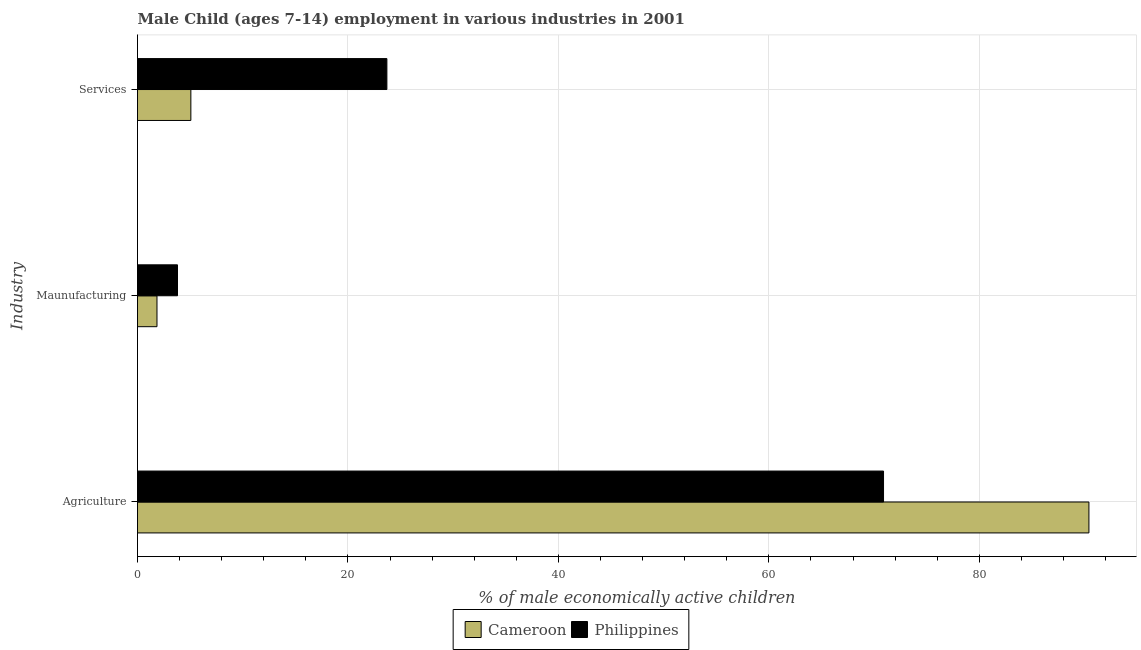How many different coloured bars are there?
Offer a very short reply. 2. How many groups of bars are there?
Offer a very short reply. 3. Are the number of bars per tick equal to the number of legend labels?
Your response must be concise. Yes. How many bars are there on the 2nd tick from the bottom?
Keep it short and to the point. 2. What is the label of the 3rd group of bars from the top?
Ensure brevity in your answer.  Agriculture. What is the percentage of economically active children in manufacturing in Cameroon?
Your response must be concise. 1.85. Across all countries, what is the maximum percentage of economically active children in services?
Provide a short and direct response. 23.7. Across all countries, what is the minimum percentage of economically active children in agriculture?
Provide a short and direct response. 70.9. In which country was the percentage of economically active children in agriculture maximum?
Provide a succinct answer. Cameroon. In which country was the percentage of economically active children in services minimum?
Your response must be concise. Cameroon. What is the total percentage of economically active children in agriculture in the graph?
Provide a short and direct response. 161.32. What is the difference between the percentage of economically active children in manufacturing in Cameroon and that in Philippines?
Provide a succinct answer. -1.95. What is the difference between the percentage of economically active children in agriculture in Cameroon and the percentage of economically active children in services in Philippines?
Your response must be concise. 66.72. What is the average percentage of economically active children in manufacturing per country?
Your response must be concise. 2.83. What is the difference between the percentage of economically active children in services and percentage of economically active children in agriculture in Cameroon?
Your response must be concise. -85.35. In how many countries, is the percentage of economically active children in manufacturing greater than 12 %?
Your response must be concise. 0. What is the ratio of the percentage of economically active children in services in Cameroon to that in Philippines?
Your response must be concise. 0.21. Is the percentage of economically active children in agriculture in Cameroon less than that in Philippines?
Your answer should be compact. No. What is the difference between the highest and the second highest percentage of economically active children in agriculture?
Make the answer very short. 19.52. What is the difference between the highest and the lowest percentage of economically active children in agriculture?
Give a very brief answer. 19.52. In how many countries, is the percentage of economically active children in services greater than the average percentage of economically active children in services taken over all countries?
Your answer should be compact. 1. Is the sum of the percentage of economically active children in agriculture in Cameroon and Philippines greater than the maximum percentage of economically active children in services across all countries?
Ensure brevity in your answer.  Yes. What does the 2nd bar from the top in Agriculture represents?
Provide a succinct answer. Cameroon. What does the 2nd bar from the bottom in Services represents?
Your answer should be compact. Philippines. Is it the case that in every country, the sum of the percentage of economically active children in agriculture and percentage of economically active children in manufacturing is greater than the percentage of economically active children in services?
Your answer should be very brief. Yes. What is the difference between two consecutive major ticks on the X-axis?
Provide a short and direct response. 20. Does the graph contain grids?
Give a very brief answer. Yes. How many legend labels are there?
Ensure brevity in your answer.  2. What is the title of the graph?
Make the answer very short. Male Child (ages 7-14) employment in various industries in 2001. What is the label or title of the X-axis?
Ensure brevity in your answer.  % of male economically active children. What is the label or title of the Y-axis?
Your response must be concise. Industry. What is the % of male economically active children in Cameroon in Agriculture?
Make the answer very short. 90.42. What is the % of male economically active children of Philippines in Agriculture?
Your answer should be very brief. 70.9. What is the % of male economically active children of Cameroon in Maunufacturing?
Offer a very short reply. 1.85. What is the % of male economically active children of Philippines in Maunufacturing?
Provide a succinct answer. 3.8. What is the % of male economically active children of Cameroon in Services?
Your response must be concise. 5.07. What is the % of male economically active children in Philippines in Services?
Provide a short and direct response. 23.7. Across all Industry, what is the maximum % of male economically active children in Cameroon?
Provide a short and direct response. 90.42. Across all Industry, what is the maximum % of male economically active children in Philippines?
Provide a short and direct response. 70.9. Across all Industry, what is the minimum % of male economically active children in Cameroon?
Offer a terse response. 1.85. What is the total % of male economically active children in Cameroon in the graph?
Your response must be concise. 97.34. What is the total % of male economically active children of Philippines in the graph?
Give a very brief answer. 98.4. What is the difference between the % of male economically active children in Cameroon in Agriculture and that in Maunufacturing?
Provide a short and direct response. 88.57. What is the difference between the % of male economically active children of Philippines in Agriculture and that in Maunufacturing?
Your answer should be compact. 67.1. What is the difference between the % of male economically active children of Cameroon in Agriculture and that in Services?
Ensure brevity in your answer.  85.35. What is the difference between the % of male economically active children in Philippines in Agriculture and that in Services?
Ensure brevity in your answer.  47.2. What is the difference between the % of male economically active children in Cameroon in Maunufacturing and that in Services?
Make the answer very short. -3.22. What is the difference between the % of male economically active children in Philippines in Maunufacturing and that in Services?
Offer a terse response. -19.9. What is the difference between the % of male economically active children of Cameroon in Agriculture and the % of male economically active children of Philippines in Maunufacturing?
Your response must be concise. 86.62. What is the difference between the % of male economically active children in Cameroon in Agriculture and the % of male economically active children in Philippines in Services?
Your answer should be very brief. 66.72. What is the difference between the % of male economically active children of Cameroon in Maunufacturing and the % of male economically active children of Philippines in Services?
Make the answer very short. -21.85. What is the average % of male economically active children of Cameroon per Industry?
Give a very brief answer. 32.45. What is the average % of male economically active children of Philippines per Industry?
Offer a very short reply. 32.8. What is the difference between the % of male economically active children in Cameroon and % of male economically active children in Philippines in Agriculture?
Your answer should be very brief. 19.52. What is the difference between the % of male economically active children of Cameroon and % of male economically active children of Philippines in Maunufacturing?
Ensure brevity in your answer.  -1.95. What is the difference between the % of male economically active children in Cameroon and % of male economically active children in Philippines in Services?
Ensure brevity in your answer.  -18.63. What is the ratio of the % of male economically active children of Cameroon in Agriculture to that in Maunufacturing?
Your answer should be very brief. 48.88. What is the ratio of the % of male economically active children of Philippines in Agriculture to that in Maunufacturing?
Keep it short and to the point. 18.66. What is the ratio of the % of male economically active children in Cameroon in Agriculture to that in Services?
Give a very brief answer. 17.83. What is the ratio of the % of male economically active children in Philippines in Agriculture to that in Services?
Offer a very short reply. 2.99. What is the ratio of the % of male economically active children of Cameroon in Maunufacturing to that in Services?
Your answer should be very brief. 0.36. What is the ratio of the % of male economically active children of Philippines in Maunufacturing to that in Services?
Offer a very short reply. 0.16. What is the difference between the highest and the second highest % of male economically active children in Cameroon?
Your answer should be very brief. 85.35. What is the difference between the highest and the second highest % of male economically active children of Philippines?
Offer a very short reply. 47.2. What is the difference between the highest and the lowest % of male economically active children in Cameroon?
Provide a succinct answer. 88.57. What is the difference between the highest and the lowest % of male economically active children of Philippines?
Offer a very short reply. 67.1. 